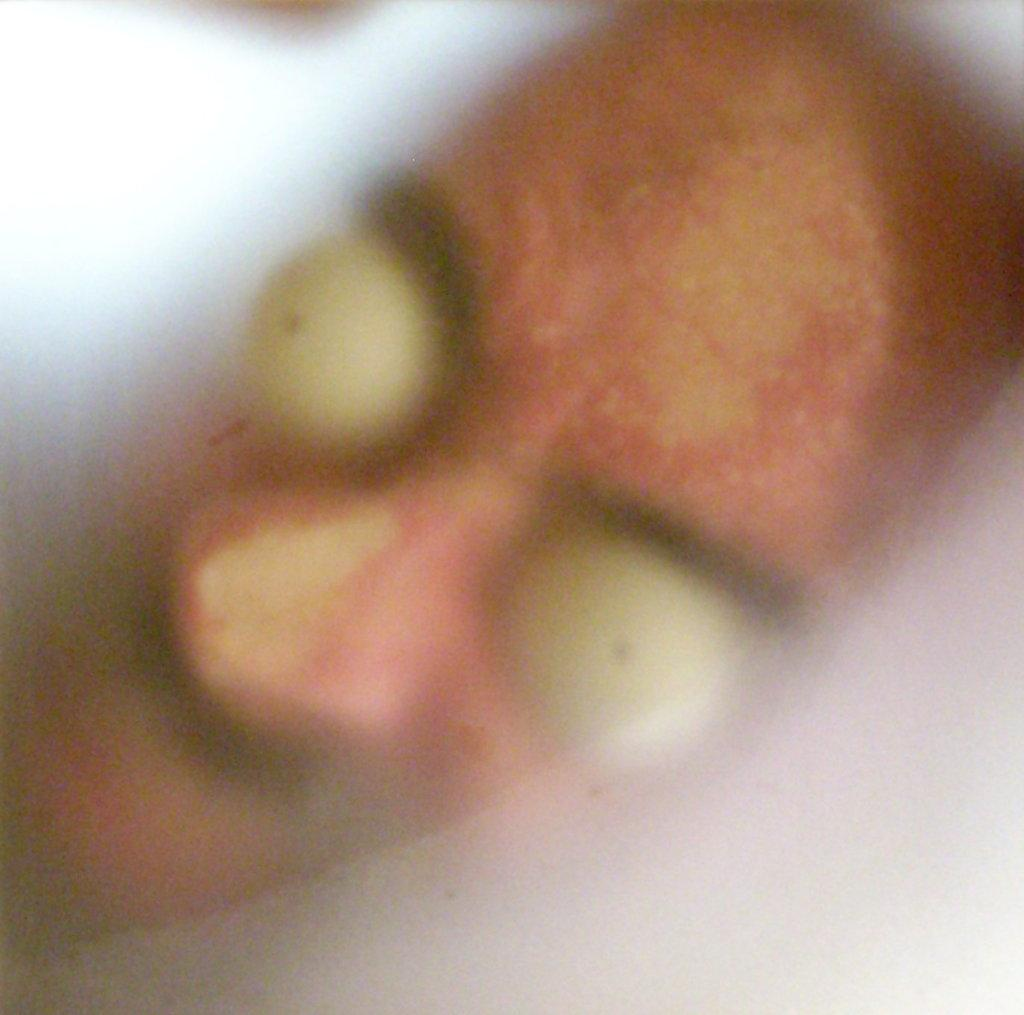What is the main subject of the image? The main subject of the image is the face of a person. Can you see any fire or flames in the image? There is no fire or flames present in the image. Is there a wheel visible in the image? There is no wheel visible in the image. Is the person taking a bath in the image? There is no indication of a bath or any water-related activity in the image. 